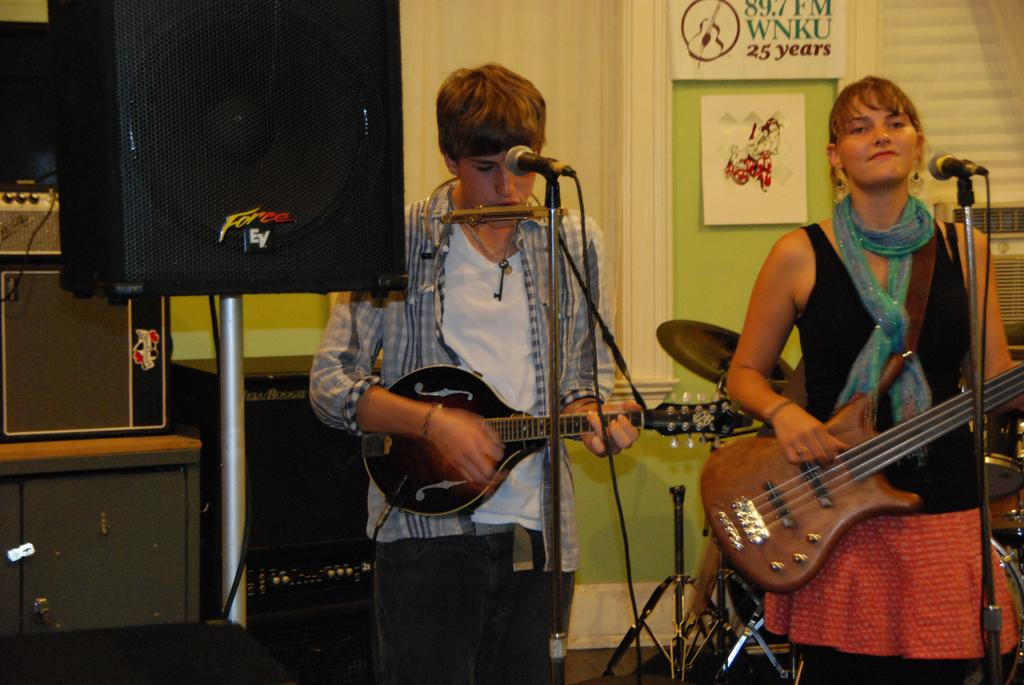How many people are in the image? There are two people in the image, a man and a woman. What are the man and woman doing in the image? They are both holding guitars and playing them. What equipment is present in the image to amplify their music? There are microphones in front of them and speakers in the background. What can be seen in the background of the image? There is a wall, posters, and speakers in the background. Can you see any balloons floating in the background of the image? No, there are no balloons present in the image. Is there a dock visible in the background of the image? No, there is no dock present in the image. 